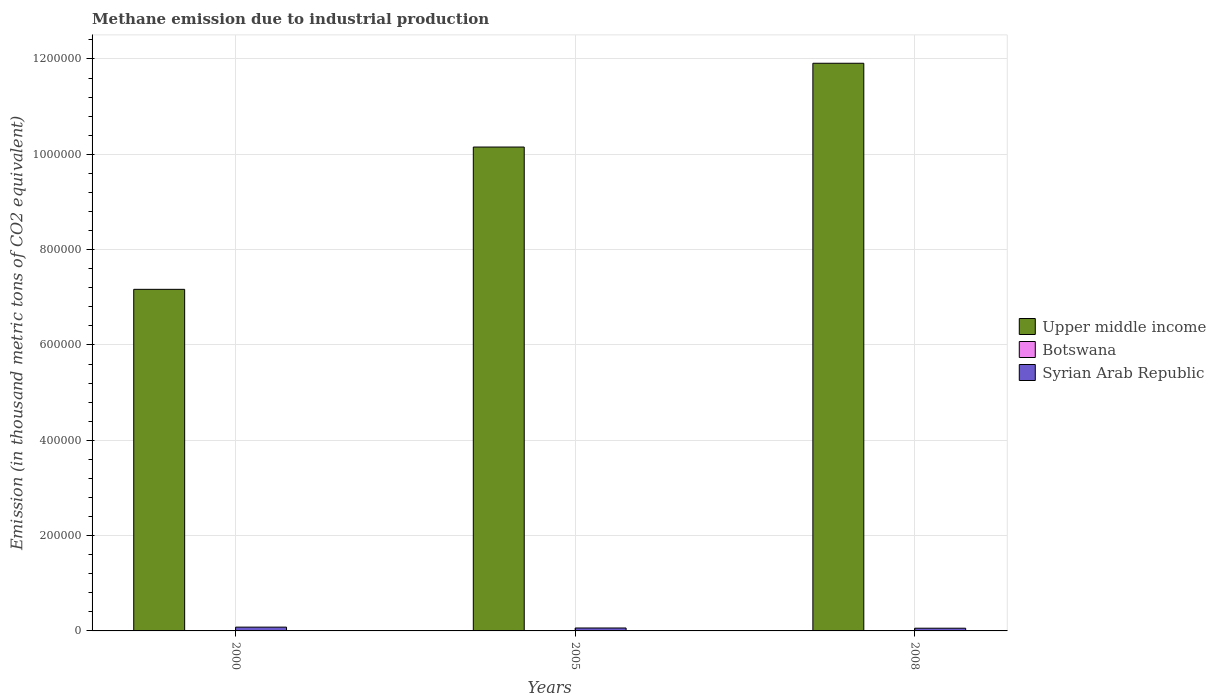How many bars are there on the 3rd tick from the left?
Keep it short and to the point. 3. In how many cases, is the number of bars for a given year not equal to the number of legend labels?
Give a very brief answer. 0. What is the amount of methane emitted in Botswana in 2008?
Make the answer very short. 455.6. Across all years, what is the maximum amount of methane emitted in Botswana?
Your response must be concise. 477.3. Across all years, what is the minimum amount of methane emitted in Upper middle income?
Provide a succinct answer. 7.17e+05. What is the total amount of methane emitted in Botswana in the graph?
Your response must be concise. 1384.2. What is the difference between the amount of methane emitted in Upper middle income in 2000 and the amount of methane emitted in Syrian Arab Republic in 2005?
Your answer should be compact. 7.11e+05. What is the average amount of methane emitted in Botswana per year?
Provide a succinct answer. 461.4. In the year 2005, what is the difference between the amount of methane emitted in Botswana and amount of methane emitted in Upper middle income?
Your answer should be very brief. -1.01e+06. In how many years, is the amount of methane emitted in Botswana greater than 440000 thousand metric tons?
Make the answer very short. 0. What is the ratio of the amount of methane emitted in Upper middle income in 2005 to that in 2008?
Your answer should be compact. 0.85. Is the difference between the amount of methane emitted in Botswana in 2000 and 2008 greater than the difference between the amount of methane emitted in Upper middle income in 2000 and 2008?
Provide a succinct answer. Yes. What is the difference between the highest and the second highest amount of methane emitted in Syrian Arab Republic?
Keep it short and to the point. 1802.9. Is the sum of the amount of methane emitted in Upper middle income in 2000 and 2005 greater than the maximum amount of methane emitted in Botswana across all years?
Your answer should be compact. Yes. What does the 3rd bar from the left in 2005 represents?
Provide a succinct answer. Syrian Arab Republic. What does the 2nd bar from the right in 2005 represents?
Offer a very short reply. Botswana. How many bars are there?
Your answer should be compact. 9. Does the graph contain any zero values?
Give a very brief answer. No. Where does the legend appear in the graph?
Your answer should be very brief. Center right. What is the title of the graph?
Your answer should be compact. Methane emission due to industrial production. Does "Burkina Faso" appear as one of the legend labels in the graph?
Provide a short and direct response. No. What is the label or title of the X-axis?
Ensure brevity in your answer.  Years. What is the label or title of the Y-axis?
Give a very brief answer. Emission (in thousand metric tons of CO2 equivalent). What is the Emission (in thousand metric tons of CO2 equivalent) in Upper middle income in 2000?
Give a very brief answer. 7.17e+05. What is the Emission (in thousand metric tons of CO2 equivalent) of Botswana in 2000?
Your response must be concise. 451.3. What is the Emission (in thousand metric tons of CO2 equivalent) in Syrian Arab Republic in 2000?
Offer a very short reply. 7954.6. What is the Emission (in thousand metric tons of CO2 equivalent) of Upper middle income in 2005?
Make the answer very short. 1.02e+06. What is the Emission (in thousand metric tons of CO2 equivalent) of Botswana in 2005?
Offer a terse response. 477.3. What is the Emission (in thousand metric tons of CO2 equivalent) in Syrian Arab Republic in 2005?
Keep it short and to the point. 6151.7. What is the Emission (in thousand metric tons of CO2 equivalent) of Upper middle income in 2008?
Offer a terse response. 1.19e+06. What is the Emission (in thousand metric tons of CO2 equivalent) of Botswana in 2008?
Make the answer very short. 455.6. What is the Emission (in thousand metric tons of CO2 equivalent) of Syrian Arab Republic in 2008?
Give a very brief answer. 5684.5. Across all years, what is the maximum Emission (in thousand metric tons of CO2 equivalent) in Upper middle income?
Offer a terse response. 1.19e+06. Across all years, what is the maximum Emission (in thousand metric tons of CO2 equivalent) of Botswana?
Ensure brevity in your answer.  477.3. Across all years, what is the maximum Emission (in thousand metric tons of CO2 equivalent) of Syrian Arab Republic?
Your answer should be very brief. 7954.6. Across all years, what is the minimum Emission (in thousand metric tons of CO2 equivalent) of Upper middle income?
Your answer should be compact. 7.17e+05. Across all years, what is the minimum Emission (in thousand metric tons of CO2 equivalent) of Botswana?
Provide a short and direct response. 451.3. Across all years, what is the minimum Emission (in thousand metric tons of CO2 equivalent) in Syrian Arab Republic?
Provide a short and direct response. 5684.5. What is the total Emission (in thousand metric tons of CO2 equivalent) of Upper middle income in the graph?
Make the answer very short. 2.92e+06. What is the total Emission (in thousand metric tons of CO2 equivalent) in Botswana in the graph?
Your answer should be compact. 1384.2. What is the total Emission (in thousand metric tons of CO2 equivalent) of Syrian Arab Republic in the graph?
Offer a very short reply. 1.98e+04. What is the difference between the Emission (in thousand metric tons of CO2 equivalent) in Upper middle income in 2000 and that in 2005?
Keep it short and to the point. -2.99e+05. What is the difference between the Emission (in thousand metric tons of CO2 equivalent) in Syrian Arab Republic in 2000 and that in 2005?
Make the answer very short. 1802.9. What is the difference between the Emission (in thousand metric tons of CO2 equivalent) of Upper middle income in 2000 and that in 2008?
Keep it short and to the point. -4.74e+05. What is the difference between the Emission (in thousand metric tons of CO2 equivalent) of Botswana in 2000 and that in 2008?
Provide a succinct answer. -4.3. What is the difference between the Emission (in thousand metric tons of CO2 equivalent) in Syrian Arab Republic in 2000 and that in 2008?
Provide a short and direct response. 2270.1. What is the difference between the Emission (in thousand metric tons of CO2 equivalent) of Upper middle income in 2005 and that in 2008?
Offer a very short reply. -1.76e+05. What is the difference between the Emission (in thousand metric tons of CO2 equivalent) of Botswana in 2005 and that in 2008?
Give a very brief answer. 21.7. What is the difference between the Emission (in thousand metric tons of CO2 equivalent) of Syrian Arab Republic in 2005 and that in 2008?
Offer a very short reply. 467.2. What is the difference between the Emission (in thousand metric tons of CO2 equivalent) in Upper middle income in 2000 and the Emission (in thousand metric tons of CO2 equivalent) in Botswana in 2005?
Ensure brevity in your answer.  7.16e+05. What is the difference between the Emission (in thousand metric tons of CO2 equivalent) in Upper middle income in 2000 and the Emission (in thousand metric tons of CO2 equivalent) in Syrian Arab Republic in 2005?
Make the answer very short. 7.11e+05. What is the difference between the Emission (in thousand metric tons of CO2 equivalent) in Botswana in 2000 and the Emission (in thousand metric tons of CO2 equivalent) in Syrian Arab Republic in 2005?
Your answer should be very brief. -5700.4. What is the difference between the Emission (in thousand metric tons of CO2 equivalent) of Upper middle income in 2000 and the Emission (in thousand metric tons of CO2 equivalent) of Botswana in 2008?
Provide a short and direct response. 7.16e+05. What is the difference between the Emission (in thousand metric tons of CO2 equivalent) in Upper middle income in 2000 and the Emission (in thousand metric tons of CO2 equivalent) in Syrian Arab Republic in 2008?
Provide a succinct answer. 7.11e+05. What is the difference between the Emission (in thousand metric tons of CO2 equivalent) of Botswana in 2000 and the Emission (in thousand metric tons of CO2 equivalent) of Syrian Arab Republic in 2008?
Offer a very short reply. -5233.2. What is the difference between the Emission (in thousand metric tons of CO2 equivalent) of Upper middle income in 2005 and the Emission (in thousand metric tons of CO2 equivalent) of Botswana in 2008?
Provide a short and direct response. 1.01e+06. What is the difference between the Emission (in thousand metric tons of CO2 equivalent) of Upper middle income in 2005 and the Emission (in thousand metric tons of CO2 equivalent) of Syrian Arab Republic in 2008?
Your answer should be compact. 1.01e+06. What is the difference between the Emission (in thousand metric tons of CO2 equivalent) of Botswana in 2005 and the Emission (in thousand metric tons of CO2 equivalent) of Syrian Arab Republic in 2008?
Ensure brevity in your answer.  -5207.2. What is the average Emission (in thousand metric tons of CO2 equivalent) of Upper middle income per year?
Give a very brief answer. 9.74e+05. What is the average Emission (in thousand metric tons of CO2 equivalent) in Botswana per year?
Make the answer very short. 461.4. What is the average Emission (in thousand metric tons of CO2 equivalent) of Syrian Arab Republic per year?
Your answer should be compact. 6596.93. In the year 2000, what is the difference between the Emission (in thousand metric tons of CO2 equivalent) in Upper middle income and Emission (in thousand metric tons of CO2 equivalent) in Botswana?
Give a very brief answer. 7.16e+05. In the year 2000, what is the difference between the Emission (in thousand metric tons of CO2 equivalent) of Upper middle income and Emission (in thousand metric tons of CO2 equivalent) of Syrian Arab Republic?
Your answer should be compact. 7.09e+05. In the year 2000, what is the difference between the Emission (in thousand metric tons of CO2 equivalent) in Botswana and Emission (in thousand metric tons of CO2 equivalent) in Syrian Arab Republic?
Provide a short and direct response. -7503.3. In the year 2005, what is the difference between the Emission (in thousand metric tons of CO2 equivalent) in Upper middle income and Emission (in thousand metric tons of CO2 equivalent) in Botswana?
Offer a terse response. 1.01e+06. In the year 2005, what is the difference between the Emission (in thousand metric tons of CO2 equivalent) of Upper middle income and Emission (in thousand metric tons of CO2 equivalent) of Syrian Arab Republic?
Give a very brief answer. 1.01e+06. In the year 2005, what is the difference between the Emission (in thousand metric tons of CO2 equivalent) in Botswana and Emission (in thousand metric tons of CO2 equivalent) in Syrian Arab Republic?
Make the answer very short. -5674.4. In the year 2008, what is the difference between the Emission (in thousand metric tons of CO2 equivalent) in Upper middle income and Emission (in thousand metric tons of CO2 equivalent) in Botswana?
Keep it short and to the point. 1.19e+06. In the year 2008, what is the difference between the Emission (in thousand metric tons of CO2 equivalent) in Upper middle income and Emission (in thousand metric tons of CO2 equivalent) in Syrian Arab Republic?
Offer a very short reply. 1.19e+06. In the year 2008, what is the difference between the Emission (in thousand metric tons of CO2 equivalent) of Botswana and Emission (in thousand metric tons of CO2 equivalent) of Syrian Arab Republic?
Your answer should be compact. -5228.9. What is the ratio of the Emission (in thousand metric tons of CO2 equivalent) in Upper middle income in 2000 to that in 2005?
Ensure brevity in your answer.  0.71. What is the ratio of the Emission (in thousand metric tons of CO2 equivalent) of Botswana in 2000 to that in 2005?
Offer a terse response. 0.95. What is the ratio of the Emission (in thousand metric tons of CO2 equivalent) of Syrian Arab Republic in 2000 to that in 2005?
Your response must be concise. 1.29. What is the ratio of the Emission (in thousand metric tons of CO2 equivalent) in Upper middle income in 2000 to that in 2008?
Offer a terse response. 0.6. What is the ratio of the Emission (in thousand metric tons of CO2 equivalent) in Botswana in 2000 to that in 2008?
Make the answer very short. 0.99. What is the ratio of the Emission (in thousand metric tons of CO2 equivalent) of Syrian Arab Republic in 2000 to that in 2008?
Provide a short and direct response. 1.4. What is the ratio of the Emission (in thousand metric tons of CO2 equivalent) in Upper middle income in 2005 to that in 2008?
Ensure brevity in your answer.  0.85. What is the ratio of the Emission (in thousand metric tons of CO2 equivalent) of Botswana in 2005 to that in 2008?
Ensure brevity in your answer.  1.05. What is the ratio of the Emission (in thousand metric tons of CO2 equivalent) in Syrian Arab Republic in 2005 to that in 2008?
Give a very brief answer. 1.08. What is the difference between the highest and the second highest Emission (in thousand metric tons of CO2 equivalent) of Upper middle income?
Your answer should be compact. 1.76e+05. What is the difference between the highest and the second highest Emission (in thousand metric tons of CO2 equivalent) in Botswana?
Offer a terse response. 21.7. What is the difference between the highest and the second highest Emission (in thousand metric tons of CO2 equivalent) of Syrian Arab Republic?
Your answer should be compact. 1802.9. What is the difference between the highest and the lowest Emission (in thousand metric tons of CO2 equivalent) of Upper middle income?
Provide a succinct answer. 4.74e+05. What is the difference between the highest and the lowest Emission (in thousand metric tons of CO2 equivalent) in Syrian Arab Republic?
Provide a succinct answer. 2270.1. 